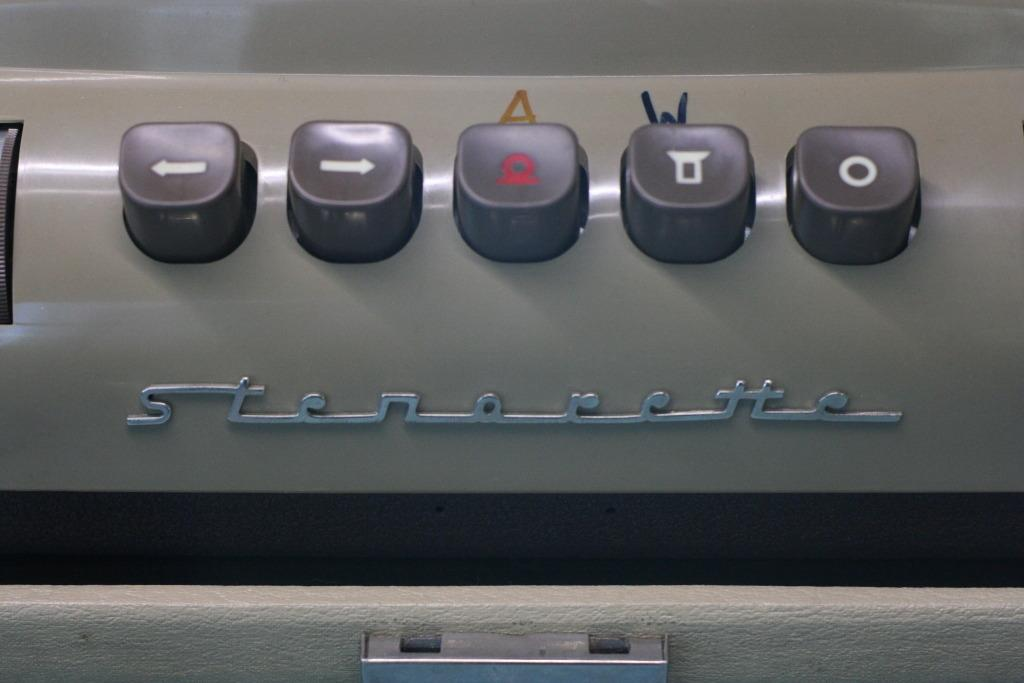<image>
Write a terse but informative summary of the picture. Below the buttons is the brand of Stenorette. 